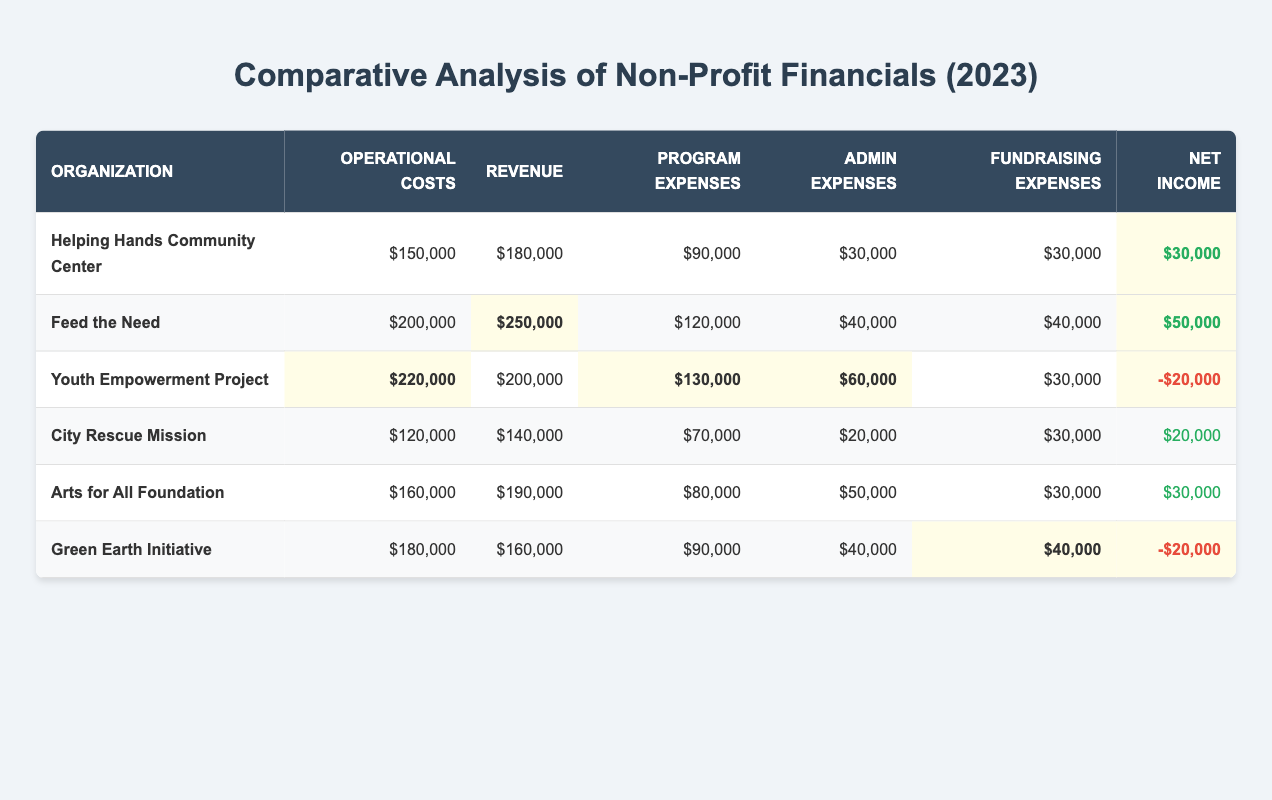What is the operational cost of "Youth Empowerment Project"? The table shows that the operational costs for "Youth Empowerment Project" are listed as $220,000.
Answer: $220,000 Which organization has the highest revenue? By comparing the revenue figures, "Feed the Need" has the highest revenue at $250,000, which is highlighted in the table.
Answer: $250,000 What is the net income of "City Rescue Mission"? According to the table, "City Rescue Mission" has a net income listed as $20,000.
Answer: $20,000 What is the total operational cost for all organizations? The operational costs can be summed up as follows: $150,000 + $200,000 + $220,000 + $120,000 + $160,000 + $180,000 = $1,030,000.
Answer: $1,030,000 How does the net income of "Green Earth Initiative" compare to that of "Helping Hands Community Center"? "Green Earth Initiative" has a net income of -$20,000 while "Helping Hands Community Center" has a net income of $30,000. Therefore, "Helping Hands Community Center" is $50,000 higher.
Answer: $50,000 What percentage of the revenue for "Feed the Need" is allocated to program expenses? The program expenses for "Feed the Need" are $120,000, and the revenue is $250,000. The percentage is calculated as ($120,000 / $250,000) * 100 = 48%.
Answer: 48% Which organization has the lowest net income? By examining the net income figures, "Youth Empowerment Project" and "Green Earth Initiative" both have negative net income, but "Youth Empowerment Project" has the lowest at -$20,000.
Answer: Youth Empowerment Project What is the average operational cost among the organizations? The average operational cost is calculated by dividing the total operational cost ($1,030,000) by the number of organizations (6). Thus, the average is $1,030,000 / 6 = $171,666.67, which can be rounded to $171,667.
Answer: $171,667 Is the fundraising expense for "Arts for All Foundation" greater than the average fundraising expense? The fundraising expense for "Arts for All Foundation" is $30,000. The average fundraising expense can be calculated: ($30,000 + $40,000 + $30,000 + $30,000 + $30,000 + $40,000) / 6 = $35,000. Since $30,000 is less than $35,000, the answer is no.
Answer: No How much more revenue does "Help Hands Community Center" have compared to its operational costs? The revenue for "Helping Hands Community Center" is $180,000, and its operational costs are $150,000. The difference is $180,000 - $150,000 = $30,000.
Answer: $30,000 